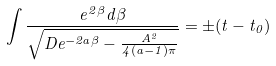Convert formula to latex. <formula><loc_0><loc_0><loc_500><loc_500>\int \frac { e ^ { 2 \beta } d \beta } { \sqrt { D e ^ { - 2 a \beta } - \frac { A ^ { 2 } } { 4 ( a - 1 ) \pi } } } = \pm ( t - t _ { 0 } )</formula> 